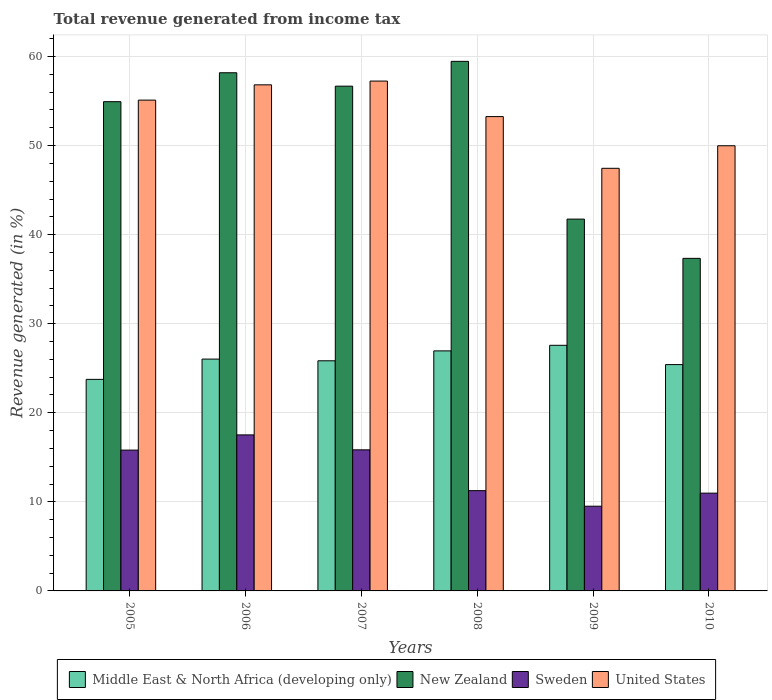How many groups of bars are there?
Offer a terse response. 6. Are the number of bars per tick equal to the number of legend labels?
Offer a very short reply. Yes. Are the number of bars on each tick of the X-axis equal?
Ensure brevity in your answer.  Yes. How many bars are there on the 6th tick from the left?
Provide a succinct answer. 4. How many bars are there on the 4th tick from the right?
Offer a terse response. 4. What is the total revenue generated in Middle East & North Africa (developing only) in 2009?
Your answer should be very brief. 27.57. Across all years, what is the maximum total revenue generated in United States?
Offer a very short reply. 57.24. Across all years, what is the minimum total revenue generated in New Zealand?
Provide a short and direct response. 37.34. In which year was the total revenue generated in United States maximum?
Keep it short and to the point. 2007. In which year was the total revenue generated in Sweden minimum?
Your response must be concise. 2009. What is the total total revenue generated in Middle East & North Africa (developing only) in the graph?
Offer a terse response. 155.55. What is the difference between the total revenue generated in Sweden in 2008 and that in 2009?
Offer a terse response. 1.75. What is the difference between the total revenue generated in United States in 2010 and the total revenue generated in Middle East & North Africa (developing only) in 2006?
Your response must be concise. 23.95. What is the average total revenue generated in Middle East & North Africa (developing only) per year?
Your answer should be very brief. 25.93. In the year 2006, what is the difference between the total revenue generated in Middle East & North Africa (developing only) and total revenue generated in Sweden?
Make the answer very short. 8.51. In how many years, is the total revenue generated in New Zealand greater than 50 %?
Ensure brevity in your answer.  4. What is the ratio of the total revenue generated in United States in 2007 to that in 2008?
Your answer should be very brief. 1.07. Is the difference between the total revenue generated in Middle East & North Africa (developing only) in 2006 and 2007 greater than the difference between the total revenue generated in Sweden in 2006 and 2007?
Your answer should be very brief. No. What is the difference between the highest and the second highest total revenue generated in Middle East & North Africa (developing only)?
Offer a terse response. 0.63. What is the difference between the highest and the lowest total revenue generated in Sweden?
Your answer should be very brief. 8.01. In how many years, is the total revenue generated in Sweden greater than the average total revenue generated in Sweden taken over all years?
Your answer should be very brief. 3. Is the sum of the total revenue generated in United States in 2005 and 2010 greater than the maximum total revenue generated in Sweden across all years?
Keep it short and to the point. Yes. Is it the case that in every year, the sum of the total revenue generated in United States and total revenue generated in Middle East & North Africa (developing only) is greater than the sum of total revenue generated in New Zealand and total revenue generated in Sweden?
Ensure brevity in your answer.  Yes. What does the 2nd bar from the left in 2009 represents?
Provide a succinct answer. New Zealand. What does the 4th bar from the right in 2006 represents?
Provide a succinct answer. Middle East & North Africa (developing only). Is it the case that in every year, the sum of the total revenue generated in Sweden and total revenue generated in United States is greater than the total revenue generated in New Zealand?
Ensure brevity in your answer.  Yes. How many bars are there?
Give a very brief answer. 24. Are all the bars in the graph horizontal?
Your answer should be very brief. No. What is the difference between two consecutive major ticks on the Y-axis?
Make the answer very short. 10. Are the values on the major ticks of Y-axis written in scientific E-notation?
Give a very brief answer. No. Does the graph contain any zero values?
Give a very brief answer. No. Does the graph contain grids?
Keep it short and to the point. Yes. Where does the legend appear in the graph?
Offer a very short reply. Bottom center. What is the title of the graph?
Keep it short and to the point. Total revenue generated from income tax. Does "Peru" appear as one of the legend labels in the graph?
Your answer should be very brief. No. What is the label or title of the X-axis?
Provide a succinct answer. Years. What is the label or title of the Y-axis?
Your answer should be very brief. Revenue generated (in %). What is the Revenue generated (in %) of Middle East & North Africa (developing only) in 2005?
Keep it short and to the point. 23.75. What is the Revenue generated (in %) of New Zealand in 2005?
Provide a short and direct response. 54.93. What is the Revenue generated (in %) in Sweden in 2005?
Offer a terse response. 15.81. What is the Revenue generated (in %) of United States in 2005?
Your response must be concise. 55.1. What is the Revenue generated (in %) in Middle East & North Africa (developing only) in 2006?
Make the answer very short. 26.03. What is the Revenue generated (in %) in New Zealand in 2006?
Your answer should be very brief. 58.17. What is the Revenue generated (in %) in Sweden in 2006?
Your response must be concise. 17.52. What is the Revenue generated (in %) of United States in 2006?
Your response must be concise. 56.82. What is the Revenue generated (in %) in Middle East & North Africa (developing only) in 2007?
Your answer should be compact. 25.84. What is the Revenue generated (in %) of New Zealand in 2007?
Your answer should be very brief. 56.67. What is the Revenue generated (in %) of Sweden in 2007?
Make the answer very short. 15.84. What is the Revenue generated (in %) of United States in 2007?
Provide a short and direct response. 57.24. What is the Revenue generated (in %) of Middle East & North Africa (developing only) in 2008?
Your answer should be compact. 26.95. What is the Revenue generated (in %) of New Zealand in 2008?
Offer a very short reply. 59.45. What is the Revenue generated (in %) in Sweden in 2008?
Your response must be concise. 11.26. What is the Revenue generated (in %) in United States in 2008?
Ensure brevity in your answer.  53.25. What is the Revenue generated (in %) in Middle East & North Africa (developing only) in 2009?
Your response must be concise. 27.57. What is the Revenue generated (in %) in New Zealand in 2009?
Make the answer very short. 41.74. What is the Revenue generated (in %) in Sweden in 2009?
Provide a succinct answer. 9.51. What is the Revenue generated (in %) of United States in 2009?
Give a very brief answer. 47.45. What is the Revenue generated (in %) in Middle East & North Africa (developing only) in 2010?
Offer a very short reply. 25.41. What is the Revenue generated (in %) in New Zealand in 2010?
Keep it short and to the point. 37.34. What is the Revenue generated (in %) in Sweden in 2010?
Make the answer very short. 10.98. What is the Revenue generated (in %) of United States in 2010?
Your response must be concise. 49.98. Across all years, what is the maximum Revenue generated (in %) of Middle East & North Africa (developing only)?
Offer a very short reply. 27.57. Across all years, what is the maximum Revenue generated (in %) of New Zealand?
Keep it short and to the point. 59.45. Across all years, what is the maximum Revenue generated (in %) of Sweden?
Offer a very short reply. 17.52. Across all years, what is the maximum Revenue generated (in %) of United States?
Make the answer very short. 57.24. Across all years, what is the minimum Revenue generated (in %) of Middle East & North Africa (developing only)?
Give a very brief answer. 23.75. Across all years, what is the minimum Revenue generated (in %) of New Zealand?
Your answer should be very brief. 37.34. Across all years, what is the minimum Revenue generated (in %) of Sweden?
Provide a short and direct response. 9.51. Across all years, what is the minimum Revenue generated (in %) of United States?
Ensure brevity in your answer.  47.45. What is the total Revenue generated (in %) in Middle East & North Africa (developing only) in the graph?
Your response must be concise. 155.55. What is the total Revenue generated (in %) of New Zealand in the graph?
Give a very brief answer. 308.3. What is the total Revenue generated (in %) in Sweden in the graph?
Offer a terse response. 80.91. What is the total Revenue generated (in %) of United States in the graph?
Your response must be concise. 319.84. What is the difference between the Revenue generated (in %) in Middle East & North Africa (developing only) in 2005 and that in 2006?
Ensure brevity in your answer.  -2.28. What is the difference between the Revenue generated (in %) of New Zealand in 2005 and that in 2006?
Make the answer very short. -3.25. What is the difference between the Revenue generated (in %) in Sweden in 2005 and that in 2006?
Ensure brevity in your answer.  -1.71. What is the difference between the Revenue generated (in %) of United States in 2005 and that in 2006?
Make the answer very short. -1.72. What is the difference between the Revenue generated (in %) of Middle East & North Africa (developing only) in 2005 and that in 2007?
Your answer should be very brief. -2.09. What is the difference between the Revenue generated (in %) of New Zealand in 2005 and that in 2007?
Make the answer very short. -1.74. What is the difference between the Revenue generated (in %) in Sweden in 2005 and that in 2007?
Your answer should be compact. -0.03. What is the difference between the Revenue generated (in %) of United States in 2005 and that in 2007?
Offer a terse response. -2.14. What is the difference between the Revenue generated (in %) in Middle East & North Africa (developing only) in 2005 and that in 2008?
Ensure brevity in your answer.  -3.2. What is the difference between the Revenue generated (in %) of New Zealand in 2005 and that in 2008?
Give a very brief answer. -4.53. What is the difference between the Revenue generated (in %) of Sweden in 2005 and that in 2008?
Give a very brief answer. 4.55. What is the difference between the Revenue generated (in %) in United States in 2005 and that in 2008?
Provide a short and direct response. 1.85. What is the difference between the Revenue generated (in %) of Middle East & North Africa (developing only) in 2005 and that in 2009?
Offer a very short reply. -3.82. What is the difference between the Revenue generated (in %) of New Zealand in 2005 and that in 2009?
Ensure brevity in your answer.  13.18. What is the difference between the Revenue generated (in %) in Sweden in 2005 and that in 2009?
Make the answer very short. 6.3. What is the difference between the Revenue generated (in %) of United States in 2005 and that in 2009?
Ensure brevity in your answer.  7.65. What is the difference between the Revenue generated (in %) in Middle East & North Africa (developing only) in 2005 and that in 2010?
Provide a short and direct response. -1.66. What is the difference between the Revenue generated (in %) in New Zealand in 2005 and that in 2010?
Make the answer very short. 17.59. What is the difference between the Revenue generated (in %) of Sweden in 2005 and that in 2010?
Provide a short and direct response. 4.83. What is the difference between the Revenue generated (in %) in United States in 2005 and that in 2010?
Offer a terse response. 5.12. What is the difference between the Revenue generated (in %) in Middle East & North Africa (developing only) in 2006 and that in 2007?
Ensure brevity in your answer.  0.19. What is the difference between the Revenue generated (in %) of New Zealand in 2006 and that in 2007?
Give a very brief answer. 1.5. What is the difference between the Revenue generated (in %) in Sweden in 2006 and that in 2007?
Your answer should be very brief. 1.68. What is the difference between the Revenue generated (in %) in United States in 2006 and that in 2007?
Your response must be concise. -0.42. What is the difference between the Revenue generated (in %) of Middle East & North Africa (developing only) in 2006 and that in 2008?
Keep it short and to the point. -0.92. What is the difference between the Revenue generated (in %) of New Zealand in 2006 and that in 2008?
Your response must be concise. -1.28. What is the difference between the Revenue generated (in %) of Sweden in 2006 and that in 2008?
Offer a very short reply. 6.26. What is the difference between the Revenue generated (in %) in United States in 2006 and that in 2008?
Make the answer very short. 3.57. What is the difference between the Revenue generated (in %) in Middle East & North Africa (developing only) in 2006 and that in 2009?
Your response must be concise. -1.55. What is the difference between the Revenue generated (in %) of New Zealand in 2006 and that in 2009?
Provide a succinct answer. 16.43. What is the difference between the Revenue generated (in %) of Sweden in 2006 and that in 2009?
Make the answer very short. 8.01. What is the difference between the Revenue generated (in %) in United States in 2006 and that in 2009?
Your answer should be very brief. 9.37. What is the difference between the Revenue generated (in %) of Middle East & North Africa (developing only) in 2006 and that in 2010?
Give a very brief answer. 0.62. What is the difference between the Revenue generated (in %) in New Zealand in 2006 and that in 2010?
Ensure brevity in your answer.  20.84. What is the difference between the Revenue generated (in %) in Sweden in 2006 and that in 2010?
Make the answer very short. 6.54. What is the difference between the Revenue generated (in %) in United States in 2006 and that in 2010?
Provide a short and direct response. 6.84. What is the difference between the Revenue generated (in %) in Middle East & North Africa (developing only) in 2007 and that in 2008?
Your answer should be very brief. -1.11. What is the difference between the Revenue generated (in %) in New Zealand in 2007 and that in 2008?
Offer a terse response. -2.79. What is the difference between the Revenue generated (in %) of Sweden in 2007 and that in 2008?
Provide a short and direct response. 4.58. What is the difference between the Revenue generated (in %) of United States in 2007 and that in 2008?
Provide a succinct answer. 3.99. What is the difference between the Revenue generated (in %) of Middle East & North Africa (developing only) in 2007 and that in 2009?
Your answer should be very brief. -1.74. What is the difference between the Revenue generated (in %) of New Zealand in 2007 and that in 2009?
Ensure brevity in your answer.  14.93. What is the difference between the Revenue generated (in %) of Sweden in 2007 and that in 2009?
Your answer should be very brief. 6.33. What is the difference between the Revenue generated (in %) of United States in 2007 and that in 2009?
Give a very brief answer. 9.79. What is the difference between the Revenue generated (in %) in Middle East & North Africa (developing only) in 2007 and that in 2010?
Provide a short and direct response. 0.43. What is the difference between the Revenue generated (in %) of New Zealand in 2007 and that in 2010?
Provide a succinct answer. 19.33. What is the difference between the Revenue generated (in %) in Sweden in 2007 and that in 2010?
Make the answer very short. 4.86. What is the difference between the Revenue generated (in %) in United States in 2007 and that in 2010?
Make the answer very short. 7.26. What is the difference between the Revenue generated (in %) of Middle East & North Africa (developing only) in 2008 and that in 2009?
Your response must be concise. -0.63. What is the difference between the Revenue generated (in %) of New Zealand in 2008 and that in 2009?
Your response must be concise. 17.71. What is the difference between the Revenue generated (in %) of Sweden in 2008 and that in 2009?
Your answer should be very brief. 1.75. What is the difference between the Revenue generated (in %) in United States in 2008 and that in 2009?
Make the answer very short. 5.81. What is the difference between the Revenue generated (in %) of Middle East & North Africa (developing only) in 2008 and that in 2010?
Make the answer very short. 1.54. What is the difference between the Revenue generated (in %) of New Zealand in 2008 and that in 2010?
Give a very brief answer. 22.12. What is the difference between the Revenue generated (in %) in Sweden in 2008 and that in 2010?
Offer a very short reply. 0.28. What is the difference between the Revenue generated (in %) in United States in 2008 and that in 2010?
Your response must be concise. 3.28. What is the difference between the Revenue generated (in %) in Middle East & North Africa (developing only) in 2009 and that in 2010?
Give a very brief answer. 2.16. What is the difference between the Revenue generated (in %) in New Zealand in 2009 and that in 2010?
Give a very brief answer. 4.41. What is the difference between the Revenue generated (in %) of Sweden in 2009 and that in 2010?
Provide a short and direct response. -1.47. What is the difference between the Revenue generated (in %) of United States in 2009 and that in 2010?
Give a very brief answer. -2.53. What is the difference between the Revenue generated (in %) in Middle East & North Africa (developing only) in 2005 and the Revenue generated (in %) in New Zealand in 2006?
Provide a succinct answer. -34.42. What is the difference between the Revenue generated (in %) of Middle East & North Africa (developing only) in 2005 and the Revenue generated (in %) of Sweden in 2006?
Make the answer very short. 6.23. What is the difference between the Revenue generated (in %) in Middle East & North Africa (developing only) in 2005 and the Revenue generated (in %) in United States in 2006?
Offer a terse response. -33.07. What is the difference between the Revenue generated (in %) in New Zealand in 2005 and the Revenue generated (in %) in Sweden in 2006?
Keep it short and to the point. 37.41. What is the difference between the Revenue generated (in %) of New Zealand in 2005 and the Revenue generated (in %) of United States in 2006?
Offer a very short reply. -1.89. What is the difference between the Revenue generated (in %) in Sweden in 2005 and the Revenue generated (in %) in United States in 2006?
Your response must be concise. -41.01. What is the difference between the Revenue generated (in %) in Middle East & North Africa (developing only) in 2005 and the Revenue generated (in %) in New Zealand in 2007?
Offer a terse response. -32.92. What is the difference between the Revenue generated (in %) in Middle East & North Africa (developing only) in 2005 and the Revenue generated (in %) in Sweden in 2007?
Provide a succinct answer. 7.91. What is the difference between the Revenue generated (in %) of Middle East & North Africa (developing only) in 2005 and the Revenue generated (in %) of United States in 2007?
Provide a succinct answer. -33.49. What is the difference between the Revenue generated (in %) of New Zealand in 2005 and the Revenue generated (in %) of Sweden in 2007?
Ensure brevity in your answer.  39.09. What is the difference between the Revenue generated (in %) of New Zealand in 2005 and the Revenue generated (in %) of United States in 2007?
Make the answer very short. -2.31. What is the difference between the Revenue generated (in %) of Sweden in 2005 and the Revenue generated (in %) of United States in 2007?
Your response must be concise. -41.43. What is the difference between the Revenue generated (in %) of Middle East & North Africa (developing only) in 2005 and the Revenue generated (in %) of New Zealand in 2008?
Offer a terse response. -35.7. What is the difference between the Revenue generated (in %) in Middle East & North Africa (developing only) in 2005 and the Revenue generated (in %) in Sweden in 2008?
Ensure brevity in your answer.  12.49. What is the difference between the Revenue generated (in %) of Middle East & North Africa (developing only) in 2005 and the Revenue generated (in %) of United States in 2008?
Offer a very short reply. -29.5. What is the difference between the Revenue generated (in %) in New Zealand in 2005 and the Revenue generated (in %) in Sweden in 2008?
Provide a succinct answer. 43.67. What is the difference between the Revenue generated (in %) of New Zealand in 2005 and the Revenue generated (in %) of United States in 2008?
Your answer should be very brief. 1.67. What is the difference between the Revenue generated (in %) of Sweden in 2005 and the Revenue generated (in %) of United States in 2008?
Make the answer very short. -37.44. What is the difference between the Revenue generated (in %) of Middle East & North Africa (developing only) in 2005 and the Revenue generated (in %) of New Zealand in 2009?
Offer a very short reply. -17.99. What is the difference between the Revenue generated (in %) in Middle East & North Africa (developing only) in 2005 and the Revenue generated (in %) in Sweden in 2009?
Your answer should be compact. 14.24. What is the difference between the Revenue generated (in %) of Middle East & North Africa (developing only) in 2005 and the Revenue generated (in %) of United States in 2009?
Give a very brief answer. -23.7. What is the difference between the Revenue generated (in %) in New Zealand in 2005 and the Revenue generated (in %) in Sweden in 2009?
Keep it short and to the point. 45.42. What is the difference between the Revenue generated (in %) in New Zealand in 2005 and the Revenue generated (in %) in United States in 2009?
Offer a terse response. 7.48. What is the difference between the Revenue generated (in %) in Sweden in 2005 and the Revenue generated (in %) in United States in 2009?
Your answer should be compact. -31.64. What is the difference between the Revenue generated (in %) in Middle East & North Africa (developing only) in 2005 and the Revenue generated (in %) in New Zealand in 2010?
Provide a short and direct response. -13.59. What is the difference between the Revenue generated (in %) in Middle East & North Africa (developing only) in 2005 and the Revenue generated (in %) in Sweden in 2010?
Ensure brevity in your answer.  12.77. What is the difference between the Revenue generated (in %) of Middle East & North Africa (developing only) in 2005 and the Revenue generated (in %) of United States in 2010?
Keep it short and to the point. -26.23. What is the difference between the Revenue generated (in %) of New Zealand in 2005 and the Revenue generated (in %) of Sweden in 2010?
Make the answer very short. 43.95. What is the difference between the Revenue generated (in %) of New Zealand in 2005 and the Revenue generated (in %) of United States in 2010?
Offer a terse response. 4.95. What is the difference between the Revenue generated (in %) of Sweden in 2005 and the Revenue generated (in %) of United States in 2010?
Keep it short and to the point. -34.17. What is the difference between the Revenue generated (in %) in Middle East & North Africa (developing only) in 2006 and the Revenue generated (in %) in New Zealand in 2007?
Make the answer very short. -30.64. What is the difference between the Revenue generated (in %) of Middle East & North Africa (developing only) in 2006 and the Revenue generated (in %) of Sweden in 2007?
Your response must be concise. 10.19. What is the difference between the Revenue generated (in %) of Middle East & North Africa (developing only) in 2006 and the Revenue generated (in %) of United States in 2007?
Offer a very short reply. -31.21. What is the difference between the Revenue generated (in %) of New Zealand in 2006 and the Revenue generated (in %) of Sweden in 2007?
Keep it short and to the point. 42.33. What is the difference between the Revenue generated (in %) in New Zealand in 2006 and the Revenue generated (in %) in United States in 2007?
Ensure brevity in your answer.  0.93. What is the difference between the Revenue generated (in %) in Sweden in 2006 and the Revenue generated (in %) in United States in 2007?
Make the answer very short. -39.72. What is the difference between the Revenue generated (in %) in Middle East & North Africa (developing only) in 2006 and the Revenue generated (in %) in New Zealand in 2008?
Make the answer very short. -33.43. What is the difference between the Revenue generated (in %) of Middle East & North Africa (developing only) in 2006 and the Revenue generated (in %) of Sweden in 2008?
Offer a very short reply. 14.77. What is the difference between the Revenue generated (in %) in Middle East & North Africa (developing only) in 2006 and the Revenue generated (in %) in United States in 2008?
Give a very brief answer. -27.22. What is the difference between the Revenue generated (in %) in New Zealand in 2006 and the Revenue generated (in %) in Sweden in 2008?
Offer a terse response. 46.91. What is the difference between the Revenue generated (in %) in New Zealand in 2006 and the Revenue generated (in %) in United States in 2008?
Make the answer very short. 4.92. What is the difference between the Revenue generated (in %) of Sweden in 2006 and the Revenue generated (in %) of United States in 2008?
Ensure brevity in your answer.  -35.74. What is the difference between the Revenue generated (in %) of Middle East & North Africa (developing only) in 2006 and the Revenue generated (in %) of New Zealand in 2009?
Offer a terse response. -15.72. What is the difference between the Revenue generated (in %) of Middle East & North Africa (developing only) in 2006 and the Revenue generated (in %) of Sweden in 2009?
Your response must be concise. 16.52. What is the difference between the Revenue generated (in %) in Middle East & North Africa (developing only) in 2006 and the Revenue generated (in %) in United States in 2009?
Make the answer very short. -21.42. What is the difference between the Revenue generated (in %) in New Zealand in 2006 and the Revenue generated (in %) in Sweden in 2009?
Your answer should be very brief. 48.66. What is the difference between the Revenue generated (in %) of New Zealand in 2006 and the Revenue generated (in %) of United States in 2009?
Ensure brevity in your answer.  10.73. What is the difference between the Revenue generated (in %) in Sweden in 2006 and the Revenue generated (in %) in United States in 2009?
Your response must be concise. -29.93. What is the difference between the Revenue generated (in %) of Middle East & North Africa (developing only) in 2006 and the Revenue generated (in %) of New Zealand in 2010?
Keep it short and to the point. -11.31. What is the difference between the Revenue generated (in %) in Middle East & North Africa (developing only) in 2006 and the Revenue generated (in %) in Sweden in 2010?
Your response must be concise. 15.05. What is the difference between the Revenue generated (in %) in Middle East & North Africa (developing only) in 2006 and the Revenue generated (in %) in United States in 2010?
Provide a short and direct response. -23.95. What is the difference between the Revenue generated (in %) in New Zealand in 2006 and the Revenue generated (in %) in Sweden in 2010?
Provide a short and direct response. 47.2. What is the difference between the Revenue generated (in %) in New Zealand in 2006 and the Revenue generated (in %) in United States in 2010?
Your answer should be very brief. 8.2. What is the difference between the Revenue generated (in %) of Sweden in 2006 and the Revenue generated (in %) of United States in 2010?
Make the answer very short. -32.46. What is the difference between the Revenue generated (in %) in Middle East & North Africa (developing only) in 2007 and the Revenue generated (in %) in New Zealand in 2008?
Keep it short and to the point. -33.62. What is the difference between the Revenue generated (in %) in Middle East & North Africa (developing only) in 2007 and the Revenue generated (in %) in Sweden in 2008?
Your answer should be very brief. 14.58. What is the difference between the Revenue generated (in %) of Middle East & North Africa (developing only) in 2007 and the Revenue generated (in %) of United States in 2008?
Offer a terse response. -27.42. What is the difference between the Revenue generated (in %) in New Zealand in 2007 and the Revenue generated (in %) in Sweden in 2008?
Give a very brief answer. 45.41. What is the difference between the Revenue generated (in %) in New Zealand in 2007 and the Revenue generated (in %) in United States in 2008?
Offer a very short reply. 3.42. What is the difference between the Revenue generated (in %) in Sweden in 2007 and the Revenue generated (in %) in United States in 2008?
Keep it short and to the point. -37.41. What is the difference between the Revenue generated (in %) in Middle East & North Africa (developing only) in 2007 and the Revenue generated (in %) in New Zealand in 2009?
Offer a terse response. -15.91. What is the difference between the Revenue generated (in %) of Middle East & North Africa (developing only) in 2007 and the Revenue generated (in %) of Sweden in 2009?
Ensure brevity in your answer.  16.33. What is the difference between the Revenue generated (in %) in Middle East & North Africa (developing only) in 2007 and the Revenue generated (in %) in United States in 2009?
Give a very brief answer. -21.61. What is the difference between the Revenue generated (in %) of New Zealand in 2007 and the Revenue generated (in %) of Sweden in 2009?
Provide a short and direct response. 47.16. What is the difference between the Revenue generated (in %) in New Zealand in 2007 and the Revenue generated (in %) in United States in 2009?
Ensure brevity in your answer.  9.22. What is the difference between the Revenue generated (in %) of Sweden in 2007 and the Revenue generated (in %) of United States in 2009?
Keep it short and to the point. -31.61. What is the difference between the Revenue generated (in %) in Middle East & North Africa (developing only) in 2007 and the Revenue generated (in %) in New Zealand in 2010?
Ensure brevity in your answer.  -11.5. What is the difference between the Revenue generated (in %) of Middle East & North Africa (developing only) in 2007 and the Revenue generated (in %) of Sweden in 2010?
Provide a succinct answer. 14.86. What is the difference between the Revenue generated (in %) in Middle East & North Africa (developing only) in 2007 and the Revenue generated (in %) in United States in 2010?
Keep it short and to the point. -24.14. What is the difference between the Revenue generated (in %) in New Zealand in 2007 and the Revenue generated (in %) in Sweden in 2010?
Provide a short and direct response. 45.69. What is the difference between the Revenue generated (in %) in New Zealand in 2007 and the Revenue generated (in %) in United States in 2010?
Provide a succinct answer. 6.69. What is the difference between the Revenue generated (in %) in Sweden in 2007 and the Revenue generated (in %) in United States in 2010?
Provide a short and direct response. -34.14. What is the difference between the Revenue generated (in %) in Middle East & North Africa (developing only) in 2008 and the Revenue generated (in %) in New Zealand in 2009?
Your answer should be compact. -14.79. What is the difference between the Revenue generated (in %) of Middle East & North Africa (developing only) in 2008 and the Revenue generated (in %) of Sweden in 2009?
Make the answer very short. 17.44. What is the difference between the Revenue generated (in %) in Middle East & North Africa (developing only) in 2008 and the Revenue generated (in %) in United States in 2009?
Provide a short and direct response. -20.5. What is the difference between the Revenue generated (in %) in New Zealand in 2008 and the Revenue generated (in %) in Sweden in 2009?
Ensure brevity in your answer.  49.94. What is the difference between the Revenue generated (in %) of New Zealand in 2008 and the Revenue generated (in %) of United States in 2009?
Give a very brief answer. 12.01. What is the difference between the Revenue generated (in %) in Sweden in 2008 and the Revenue generated (in %) in United States in 2009?
Ensure brevity in your answer.  -36.19. What is the difference between the Revenue generated (in %) of Middle East & North Africa (developing only) in 2008 and the Revenue generated (in %) of New Zealand in 2010?
Provide a succinct answer. -10.39. What is the difference between the Revenue generated (in %) of Middle East & North Africa (developing only) in 2008 and the Revenue generated (in %) of Sweden in 2010?
Provide a short and direct response. 15.97. What is the difference between the Revenue generated (in %) in Middle East & North Africa (developing only) in 2008 and the Revenue generated (in %) in United States in 2010?
Keep it short and to the point. -23.03. What is the difference between the Revenue generated (in %) in New Zealand in 2008 and the Revenue generated (in %) in Sweden in 2010?
Give a very brief answer. 48.48. What is the difference between the Revenue generated (in %) of New Zealand in 2008 and the Revenue generated (in %) of United States in 2010?
Give a very brief answer. 9.48. What is the difference between the Revenue generated (in %) in Sweden in 2008 and the Revenue generated (in %) in United States in 2010?
Offer a terse response. -38.72. What is the difference between the Revenue generated (in %) in Middle East & North Africa (developing only) in 2009 and the Revenue generated (in %) in New Zealand in 2010?
Keep it short and to the point. -9.76. What is the difference between the Revenue generated (in %) in Middle East & North Africa (developing only) in 2009 and the Revenue generated (in %) in Sweden in 2010?
Make the answer very short. 16.6. What is the difference between the Revenue generated (in %) of Middle East & North Africa (developing only) in 2009 and the Revenue generated (in %) of United States in 2010?
Provide a short and direct response. -22.4. What is the difference between the Revenue generated (in %) in New Zealand in 2009 and the Revenue generated (in %) in Sweden in 2010?
Provide a succinct answer. 30.77. What is the difference between the Revenue generated (in %) in New Zealand in 2009 and the Revenue generated (in %) in United States in 2010?
Your answer should be very brief. -8.23. What is the difference between the Revenue generated (in %) of Sweden in 2009 and the Revenue generated (in %) of United States in 2010?
Make the answer very short. -40.47. What is the average Revenue generated (in %) of Middle East & North Africa (developing only) per year?
Your answer should be very brief. 25.93. What is the average Revenue generated (in %) in New Zealand per year?
Provide a short and direct response. 51.38. What is the average Revenue generated (in %) of Sweden per year?
Make the answer very short. 13.49. What is the average Revenue generated (in %) of United States per year?
Keep it short and to the point. 53.31. In the year 2005, what is the difference between the Revenue generated (in %) in Middle East & North Africa (developing only) and Revenue generated (in %) in New Zealand?
Give a very brief answer. -31.17. In the year 2005, what is the difference between the Revenue generated (in %) in Middle East & North Africa (developing only) and Revenue generated (in %) in Sweden?
Keep it short and to the point. 7.94. In the year 2005, what is the difference between the Revenue generated (in %) in Middle East & North Africa (developing only) and Revenue generated (in %) in United States?
Keep it short and to the point. -31.35. In the year 2005, what is the difference between the Revenue generated (in %) of New Zealand and Revenue generated (in %) of Sweden?
Provide a short and direct response. 39.12. In the year 2005, what is the difference between the Revenue generated (in %) in New Zealand and Revenue generated (in %) in United States?
Offer a terse response. -0.18. In the year 2005, what is the difference between the Revenue generated (in %) of Sweden and Revenue generated (in %) of United States?
Your answer should be very brief. -39.29. In the year 2006, what is the difference between the Revenue generated (in %) of Middle East & North Africa (developing only) and Revenue generated (in %) of New Zealand?
Keep it short and to the point. -32.14. In the year 2006, what is the difference between the Revenue generated (in %) in Middle East & North Africa (developing only) and Revenue generated (in %) in Sweden?
Keep it short and to the point. 8.51. In the year 2006, what is the difference between the Revenue generated (in %) of Middle East & North Africa (developing only) and Revenue generated (in %) of United States?
Provide a succinct answer. -30.79. In the year 2006, what is the difference between the Revenue generated (in %) in New Zealand and Revenue generated (in %) in Sweden?
Keep it short and to the point. 40.66. In the year 2006, what is the difference between the Revenue generated (in %) of New Zealand and Revenue generated (in %) of United States?
Provide a succinct answer. 1.35. In the year 2006, what is the difference between the Revenue generated (in %) of Sweden and Revenue generated (in %) of United States?
Give a very brief answer. -39.3. In the year 2007, what is the difference between the Revenue generated (in %) in Middle East & North Africa (developing only) and Revenue generated (in %) in New Zealand?
Keep it short and to the point. -30.83. In the year 2007, what is the difference between the Revenue generated (in %) of Middle East & North Africa (developing only) and Revenue generated (in %) of Sweden?
Offer a very short reply. 10. In the year 2007, what is the difference between the Revenue generated (in %) in Middle East & North Africa (developing only) and Revenue generated (in %) in United States?
Ensure brevity in your answer.  -31.4. In the year 2007, what is the difference between the Revenue generated (in %) of New Zealand and Revenue generated (in %) of Sweden?
Ensure brevity in your answer.  40.83. In the year 2007, what is the difference between the Revenue generated (in %) of New Zealand and Revenue generated (in %) of United States?
Your response must be concise. -0.57. In the year 2007, what is the difference between the Revenue generated (in %) in Sweden and Revenue generated (in %) in United States?
Ensure brevity in your answer.  -41.4. In the year 2008, what is the difference between the Revenue generated (in %) of Middle East & North Africa (developing only) and Revenue generated (in %) of New Zealand?
Give a very brief answer. -32.5. In the year 2008, what is the difference between the Revenue generated (in %) of Middle East & North Africa (developing only) and Revenue generated (in %) of Sweden?
Offer a very short reply. 15.69. In the year 2008, what is the difference between the Revenue generated (in %) in Middle East & North Africa (developing only) and Revenue generated (in %) in United States?
Your answer should be very brief. -26.3. In the year 2008, what is the difference between the Revenue generated (in %) of New Zealand and Revenue generated (in %) of Sweden?
Your answer should be very brief. 48.2. In the year 2008, what is the difference between the Revenue generated (in %) in New Zealand and Revenue generated (in %) in United States?
Provide a succinct answer. 6.2. In the year 2008, what is the difference between the Revenue generated (in %) in Sweden and Revenue generated (in %) in United States?
Your response must be concise. -41.99. In the year 2009, what is the difference between the Revenue generated (in %) in Middle East & North Africa (developing only) and Revenue generated (in %) in New Zealand?
Offer a very short reply. -14.17. In the year 2009, what is the difference between the Revenue generated (in %) of Middle East & North Africa (developing only) and Revenue generated (in %) of Sweden?
Offer a terse response. 18.06. In the year 2009, what is the difference between the Revenue generated (in %) in Middle East & North Africa (developing only) and Revenue generated (in %) in United States?
Offer a very short reply. -19.87. In the year 2009, what is the difference between the Revenue generated (in %) in New Zealand and Revenue generated (in %) in Sweden?
Your answer should be compact. 32.23. In the year 2009, what is the difference between the Revenue generated (in %) of New Zealand and Revenue generated (in %) of United States?
Provide a short and direct response. -5.7. In the year 2009, what is the difference between the Revenue generated (in %) in Sweden and Revenue generated (in %) in United States?
Offer a very short reply. -37.94. In the year 2010, what is the difference between the Revenue generated (in %) of Middle East & North Africa (developing only) and Revenue generated (in %) of New Zealand?
Provide a succinct answer. -11.93. In the year 2010, what is the difference between the Revenue generated (in %) in Middle East & North Africa (developing only) and Revenue generated (in %) in Sweden?
Ensure brevity in your answer.  14.43. In the year 2010, what is the difference between the Revenue generated (in %) in Middle East & North Africa (developing only) and Revenue generated (in %) in United States?
Your response must be concise. -24.57. In the year 2010, what is the difference between the Revenue generated (in %) in New Zealand and Revenue generated (in %) in Sweden?
Give a very brief answer. 26.36. In the year 2010, what is the difference between the Revenue generated (in %) of New Zealand and Revenue generated (in %) of United States?
Provide a short and direct response. -12.64. In the year 2010, what is the difference between the Revenue generated (in %) in Sweden and Revenue generated (in %) in United States?
Keep it short and to the point. -39. What is the ratio of the Revenue generated (in %) of Middle East & North Africa (developing only) in 2005 to that in 2006?
Ensure brevity in your answer.  0.91. What is the ratio of the Revenue generated (in %) of New Zealand in 2005 to that in 2006?
Ensure brevity in your answer.  0.94. What is the ratio of the Revenue generated (in %) in Sweden in 2005 to that in 2006?
Your response must be concise. 0.9. What is the ratio of the Revenue generated (in %) in United States in 2005 to that in 2006?
Ensure brevity in your answer.  0.97. What is the ratio of the Revenue generated (in %) of Middle East & North Africa (developing only) in 2005 to that in 2007?
Give a very brief answer. 0.92. What is the ratio of the Revenue generated (in %) in New Zealand in 2005 to that in 2007?
Offer a terse response. 0.97. What is the ratio of the Revenue generated (in %) of United States in 2005 to that in 2007?
Offer a terse response. 0.96. What is the ratio of the Revenue generated (in %) in Middle East & North Africa (developing only) in 2005 to that in 2008?
Offer a very short reply. 0.88. What is the ratio of the Revenue generated (in %) in New Zealand in 2005 to that in 2008?
Provide a short and direct response. 0.92. What is the ratio of the Revenue generated (in %) in Sweden in 2005 to that in 2008?
Provide a succinct answer. 1.4. What is the ratio of the Revenue generated (in %) in United States in 2005 to that in 2008?
Provide a succinct answer. 1.03. What is the ratio of the Revenue generated (in %) of Middle East & North Africa (developing only) in 2005 to that in 2009?
Keep it short and to the point. 0.86. What is the ratio of the Revenue generated (in %) of New Zealand in 2005 to that in 2009?
Keep it short and to the point. 1.32. What is the ratio of the Revenue generated (in %) in Sweden in 2005 to that in 2009?
Your response must be concise. 1.66. What is the ratio of the Revenue generated (in %) in United States in 2005 to that in 2009?
Your answer should be very brief. 1.16. What is the ratio of the Revenue generated (in %) of Middle East & North Africa (developing only) in 2005 to that in 2010?
Ensure brevity in your answer.  0.93. What is the ratio of the Revenue generated (in %) in New Zealand in 2005 to that in 2010?
Your answer should be very brief. 1.47. What is the ratio of the Revenue generated (in %) in Sweden in 2005 to that in 2010?
Ensure brevity in your answer.  1.44. What is the ratio of the Revenue generated (in %) of United States in 2005 to that in 2010?
Your response must be concise. 1.1. What is the ratio of the Revenue generated (in %) in Middle East & North Africa (developing only) in 2006 to that in 2007?
Offer a very short reply. 1.01. What is the ratio of the Revenue generated (in %) of New Zealand in 2006 to that in 2007?
Keep it short and to the point. 1.03. What is the ratio of the Revenue generated (in %) in Sweden in 2006 to that in 2007?
Your response must be concise. 1.11. What is the ratio of the Revenue generated (in %) in Middle East & North Africa (developing only) in 2006 to that in 2008?
Provide a succinct answer. 0.97. What is the ratio of the Revenue generated (in %) in New Zealand in 2006 to that in 2008?
Ensure brevity in your answer.  0.98. What is the ratio of the Revenue generated (in %) of Sweden in 2006 to that in 2008?
Ensure brevity in your answer.  1.56. What is the ratio of the Revenue generated (in %) in United States in 2006 to that in 2008?
Keep it short and to the point. 1.07. What is the ratio of the Revenue generated (in %) of Middle East & North Africa (developing only) in 2006 to that in 2009?
Provide a succinct answer. 0.94. What is the ratio of the Revenue generated (in %) of New Zealand in 2006 to that in 2009?
Ensure brevity in your answer.  1.39. What is the ratio of the Revenue generated (in %) in Sweden in 2006 to that in 2009?
Your response must be concise. 1.84. What is the ratio of the Revenue generated (in %) in United States in 2006 to that in 2009?
Your answer should be very brief. 1.2. What is the ratio of the Revenue generated (in %) in Middle East & North Africa (developing only) in 2006 to that in 2010?
Offer a terse response. 1.02. What is the ratio of the Revenue generated (in %) in New Zealand in 2006 to that in 2010?
Provide a succinct answer. 1.56. What is the ratio of the Revenue generated (in %) in Sweden in 2006 to that in 2010?
Make the answer very short. 1.6. What is the ratio of the Revenue generated (in %) of United States in 2006 to that in 2010?
Your answer should be compact. 1.14. What is the ratio of the Revenue generated (in %) of Middle East & North Africa (developing only) in 2007 to that in 2008?
Ensure brevity in your answer.  0.96. What is the ratio of the Revenue generated (in %) in New Zealand in 2007 to that in 2008?
Ensure brevity in your answer.  0.95. What is the ratio of the Revenue generated (in %) in Sweden in 2007 to that in 2008?
Give a very brief answer. 1.41. What is the ratio of the Revenue generated (in %) in United States in 2007 to that in 2008?
Ensure brevity in your answer.  1.07. What is the ratio of the Revenue generated (in %) in Middle East & North Africa (developing only) in 2007 to that in 2009?
Your answer should be compact. 0.94. What is the ratio of the Revenue generated (in %) in New Zealand in 2007 to that in 2009?
Provide a succinct answer. 1.36. What is the ratio of the Revenue generated (in %) of Sweden in 2007 to that in 2009?
Provide a succinct answer. 1.67. What is the ratio of the Revenue generated (in %) of United States in 2007 to that in 2009?
Ensure brevity in your answer.  1.21. What is the ratio of the Revenue generated (in %) in Middle East & North Africa (developing only) in 2007 to that in 2010?
Provide a short and direct response. 1.02. What is the ratio of the Revenue generated (in %) of New Zealand in 2007 to that in 2010?
Keep it short and to the point. 1.52. What is the ratio of the Revenue generated (in %) of Sweden in 2007 to that in 2010?
Provide a succinct answer. 1.44. What is the ratio of the Revenue generated (in %) in United States in 2007 to that in 2010?
Ensure brevity in your answer.  1.15. What is the ratio of the Revenue generated (in %) in Middle East & North Africa (developing only) in 2008 to that in 2009?
Offer a very short reply. 0.98. What is the ratio of the Revenue generated (in %) of New Zealand in 2008 to that in 2009?
Your response must be concise. 1.42. What is the ratio of the Revenue generated (in %) in Sweden in 2008 to that in 2009?
Your answer should be very brief. 1.18. What is the ratio of the Revenue generated (in %) of United States in 2008 to that in 2009?
Ensure brevity in your answer.  1.12. What is the ratio of the Revenue generated (in %) of Middle East & North Africa (developing only) in 2008 to that in 2010?
Offer a very short reply. 1.06. What is the ratio of the Revenue generated (in %) in New Zealand in 2008 to that in 2010?
Ensure brevity in your answer.  1.59. What is the ratio of the Revenue generated (in %) in Sweden in 2008 to that in 2010?
Your answer should be compact. 1.03. What is the ratio of the Revenue generated (in %) in United States in 2008 to that in 2010?
Provide a short and direct response. 1.07. What is the ratio of the Revenue generated (in %) in Middle East & North Africa (developing only) in 2009 to that in 2010?
Your answer should be compact. 1.09. What is the ratio of the Revenue generated (in %) of New Zealand in 2009 to that in 2010?
Provide a succinct answer. 1.12. What is the ratio of the Revenue generated (in %) of Sweden in 2009 to that in 2010?
Make the answer very short. 0.87. What is the ratio of the Revenue generated (in %) in United States in 2009 to that in 2010?
Make the answer very short. 0.95. What is the difference between the highest and the second highest Revenue generated (in %) in Middle East & North Africa (developing only)?
Ensure brevity in your answer.  0.63. What is the difference between the highest and the second highest Revenue generated (in %) in New Zealand?
Provide a succinct answer. 1.28. What is the difference between the highest and the second highest Revenue generated (in %) in Sweden?
Offer a very short reply. 1.68. What is the difference between the highest and the second highest Revenue generated (in %) of United States?
Your answer should be compact. 0.42. What is the difference between the highest and the lowest Revenue generated (in %) in Middle East & North Africa (developing only)?
Offer a very short reply. 3.82. What is the difference between the highest and the lowest Revenue generated (in %) in New Zealand?
Give a very brief answer. 22.12. What is the difference between the highest and the lowest Revenue generated (in %) of Sweden?
Offer a very short reply. 8.01. What is the difference between the highest and the lowest Revenue generated (in %) of United States?
Your answer should be very brief. 9.79. 